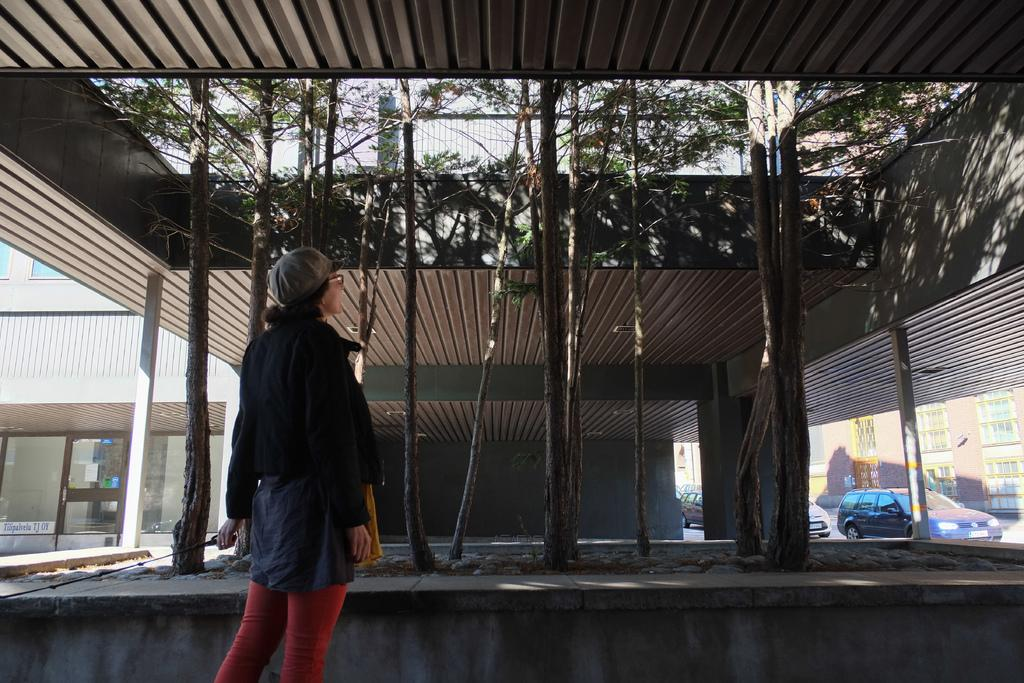What is the main subject of the image? There is a woman standing in the image. What can be seen above the woman in the image? There is a roof visible in the image. What type of natural elements are present in the image? There are trees in the middle of the image. What type of structures can be seen in the background of the image? There are buildings in the background of the image. What type of vehicles are visible in the background of the image? There are cars in the background of the image. What time of day is it in the image, based on the hour shown on the clock tower? There is no clock tower or any indication of time in the image. 